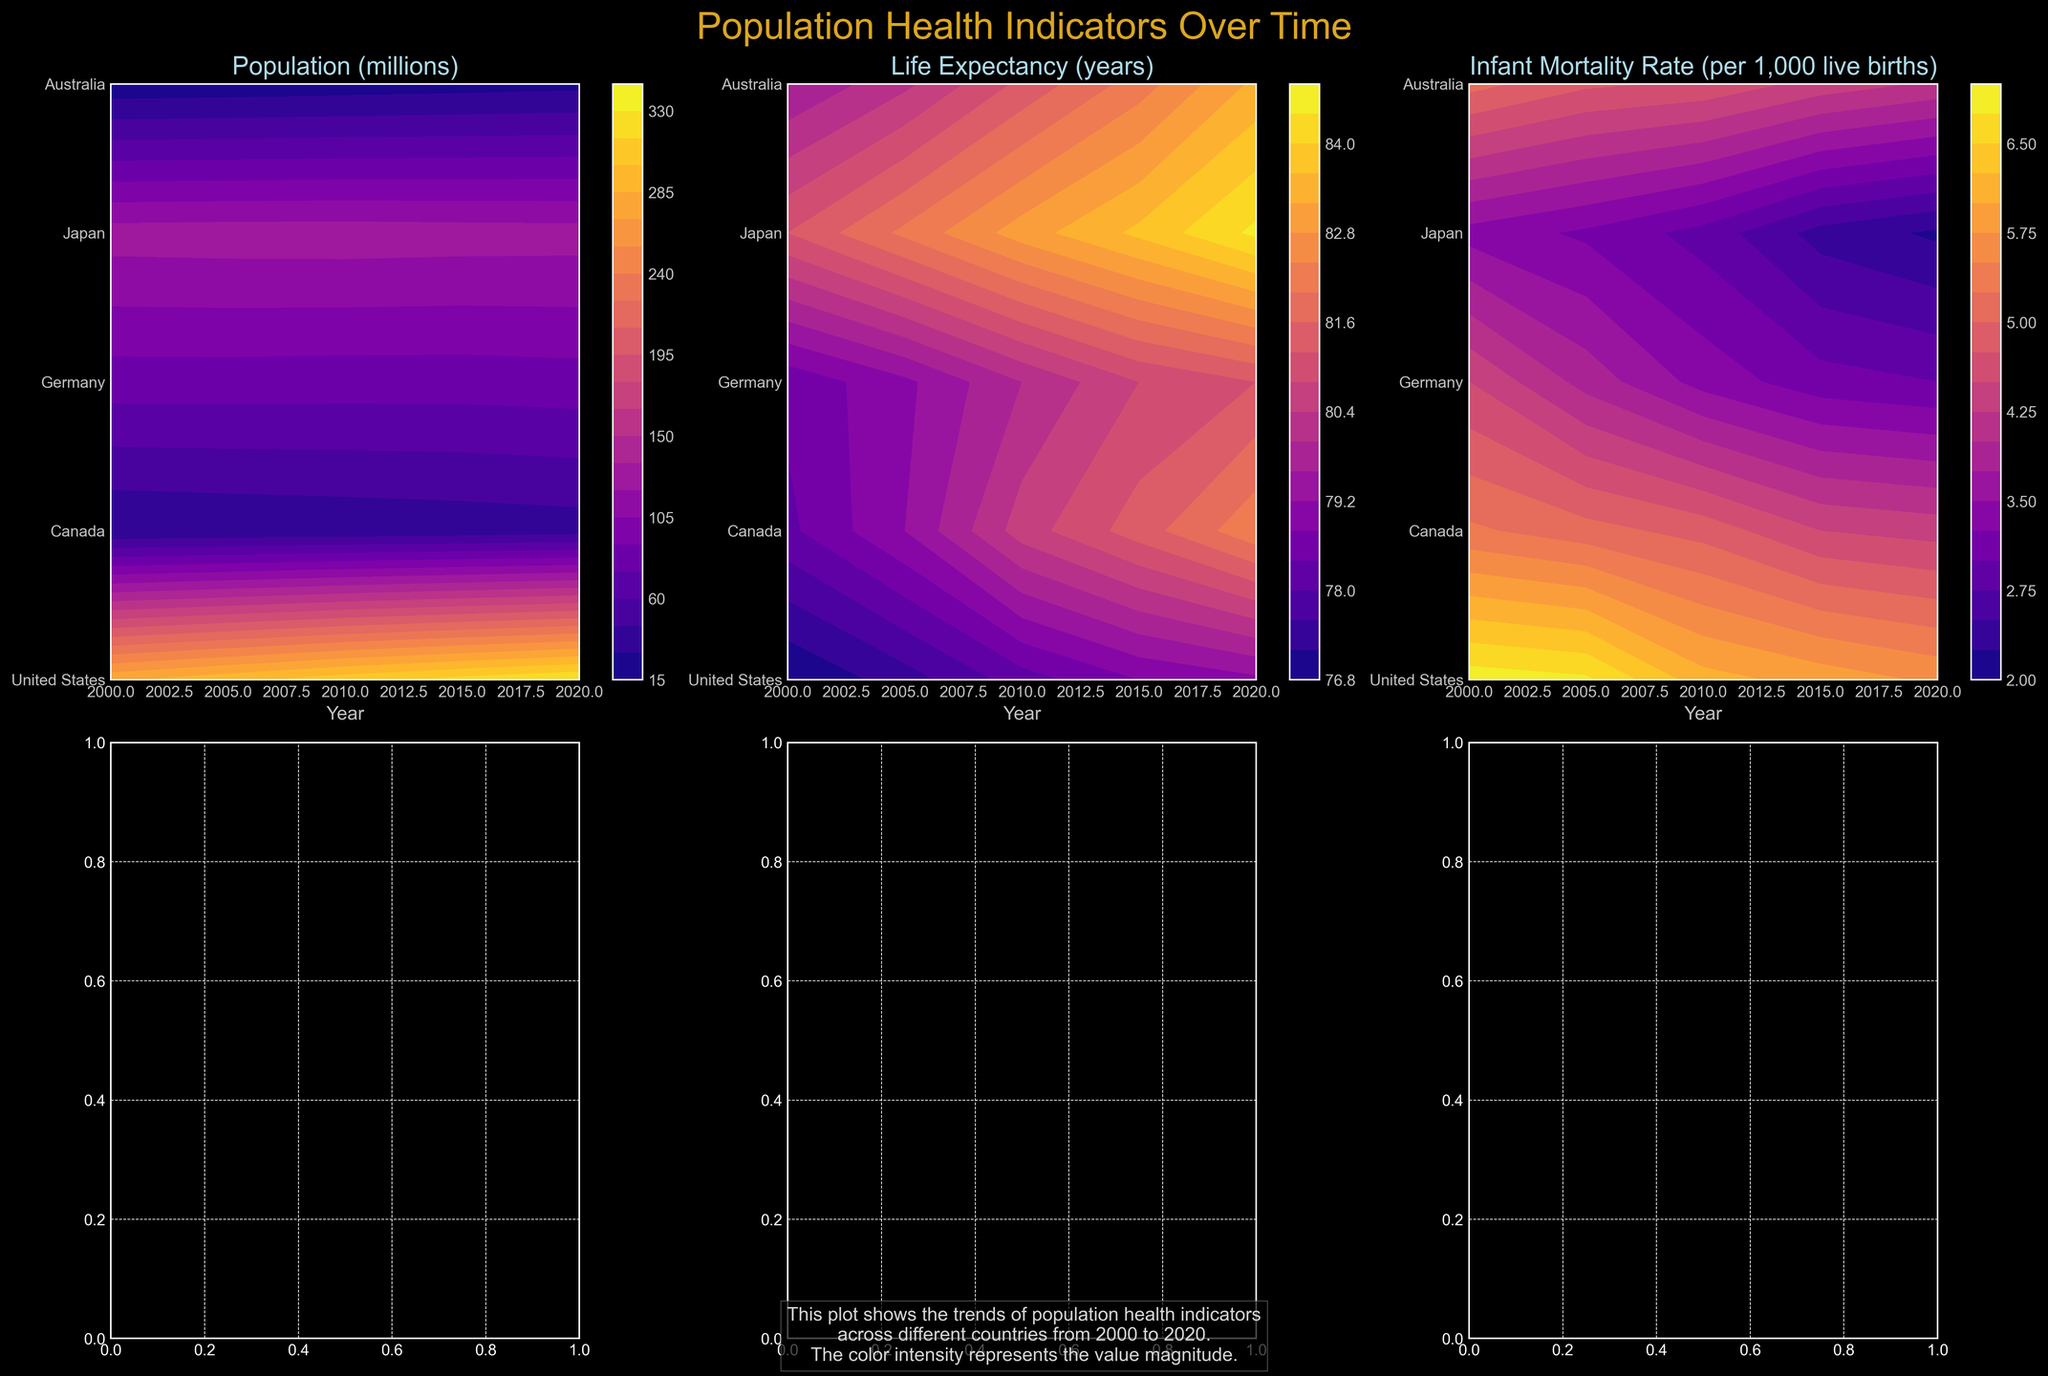How is each country labeled on the vertical axis? Each subplot has a vertical axis labeled with the names of the countries: United States, Canada, Germany, Japan, and Australia. Each label corresponds to a horizontal contour plot for each country over the years.
Answer: Country names What is the color scheme used in the plots? The plots use a plasma color map with a dark background. The colors range from darker shades representing lower values to brighter shades representing higher values.
Answer: Plasma color map How has Australia's life expectancy changed from 2000 to 2020? Observing the plot for Life Expectancy (years), the contour lines for Australia gradually shift towards higher values from 2000 to 2020, indicating an increase in life expectancy over this period.
Answer: Increased Which country had the highest life expectancy in 2020? Checking the Life Expectancy subplot and looking for the peak contours in 2020, Japan's data show the highest value, indicated by the brightest colors in that year.
Answer: Japan What trend can you see in the Infant Mortality Rate for the United States from 2000 to 2020? In the Infant Mortality Rate subplot, the contour colors for the United States from 2000 to 2020 shift from a darker to a slightly lighter shade, indicating a decrease in infant mortality rate over these years.
Answer: Decreasing trend Compare the population growth of Germany and Canada between 2000 and 2020. In the Population (millions) subplot, Germany's contour colors remain closer to the same shade, indicating relatively stable population numbers, while Canada's contours shift to brighter shades, indicating a more significant population growth.
Answer: Germany stable, Canada increased Which country saw the most significant decrease in Infant Mortality Rate from 2000 to 2020? Checking the Infant Mortality Rate subplot for the biggest color transition towards darker shades from 2000 to 2020, Japan shows the most significant decrease.
Answer: Japan What can you infer about Japan's life expectancy trend compared to other countries between 2000 and 2020? The life expectancy subplot shows Japan with the brightest contours consistently higher than other countries, indicating that Japan not only had the highest life expectancy throughout but also saw a steady increase.
Answer: Higher, steady increase Is there a visual correlation between life expectancy and infant mortality rate? Comparing the subplots of Life Expectancy and Infant Mortality Rate, countries with higher life expectancy (brighter colors) generally have lower infant mortality rates (darker colors), indicating an inverse correlation.
Answer: Inverse correlation How did Canada’s population in millions change, and what was its rate like compared to the United States from 2000 to 2020? The Population subplot shows Canada's contour lines shifting from a darker to a lighter shade, indicating growth. The United States also shows a similar trend but with a larger magnitude, seen in more distinct color changes.
Answer: Both increased, U.S. more significantly 